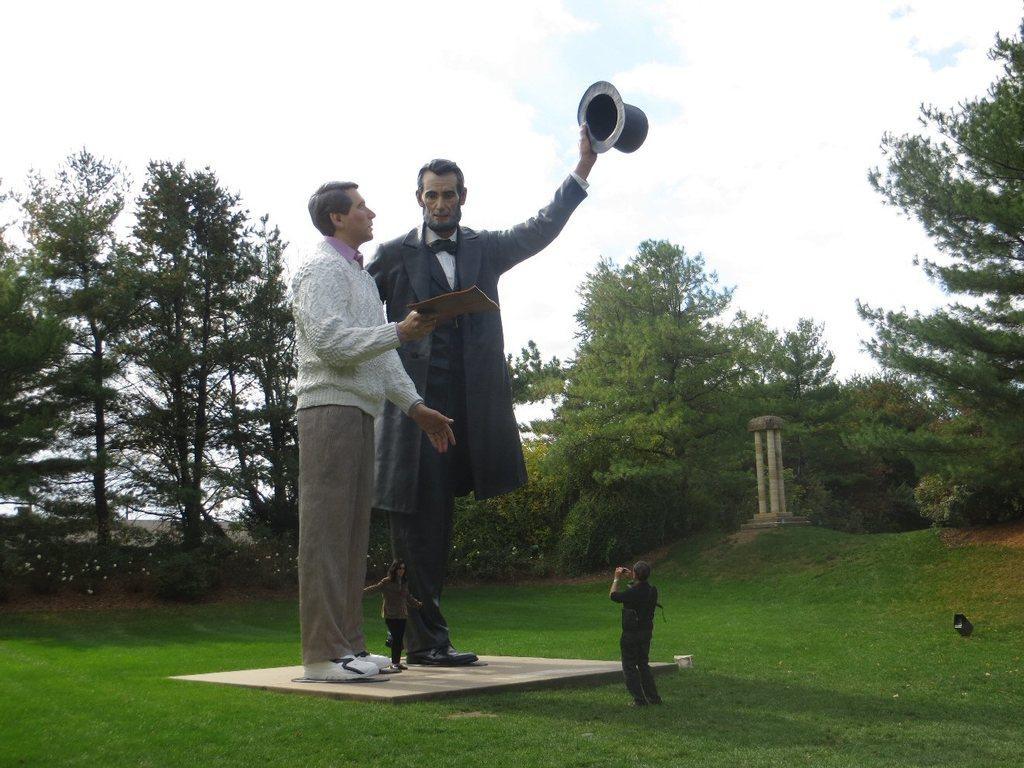Please provide a concise description of this image. In the image there are two statues in between the garden and there is a woman posing by standing in between the statues and a person is capturing the photo, in the background there are trees. 